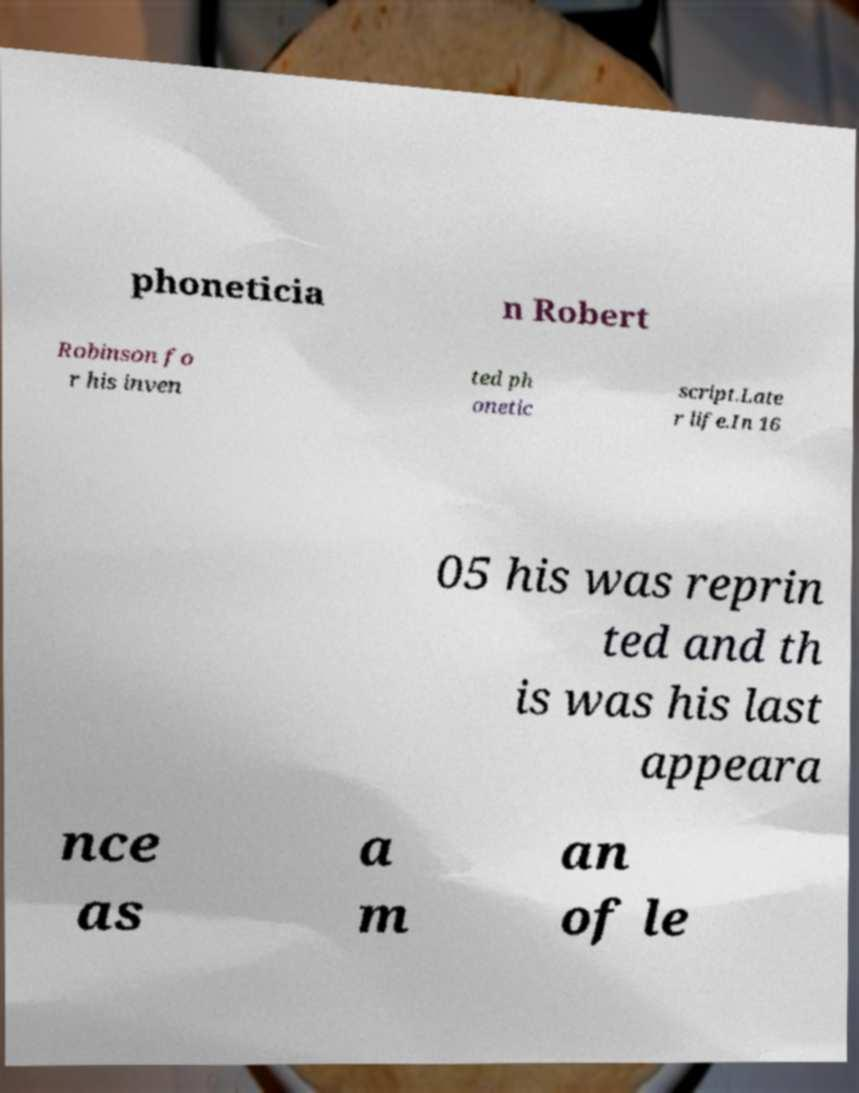I need the written content from this picture converted into text. Can you do that? phoneticia n Robert Robinson fo r his inven ted ph onetic script.Late r life.In 16 05 his was reprin ted and th is was his last appeara nce as a m an of le 